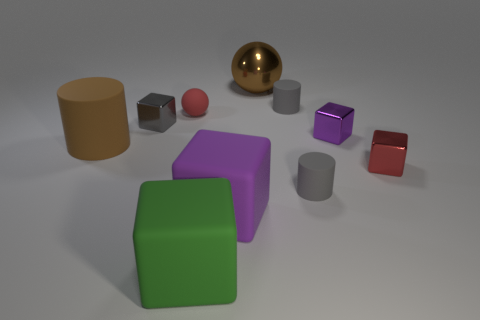Subtract all red blocks. How many gray cylinders are left? 2 Subtract all small matte cylinders. How many cylinders are left? 1 Subtract all gray cubes. How many cubes are left? 4 Subtract 1 cubes. How many cubes are left? 4 Subtract all large brown balls. Subtract all small cylinders. How many objects are left? 7 Add 8 large rubber cylinders. How many large rubber cylinders are left? 9 Add 9 small brown metallic objects. How many small brown metallic objects exist? 9 Subtract 0 red cylinders. How many objects are left? 10 Subtract all balls. How many objects are left? 8 Subtract all red cubes. Subtract all green cylinders. How many cubes are left? 4 